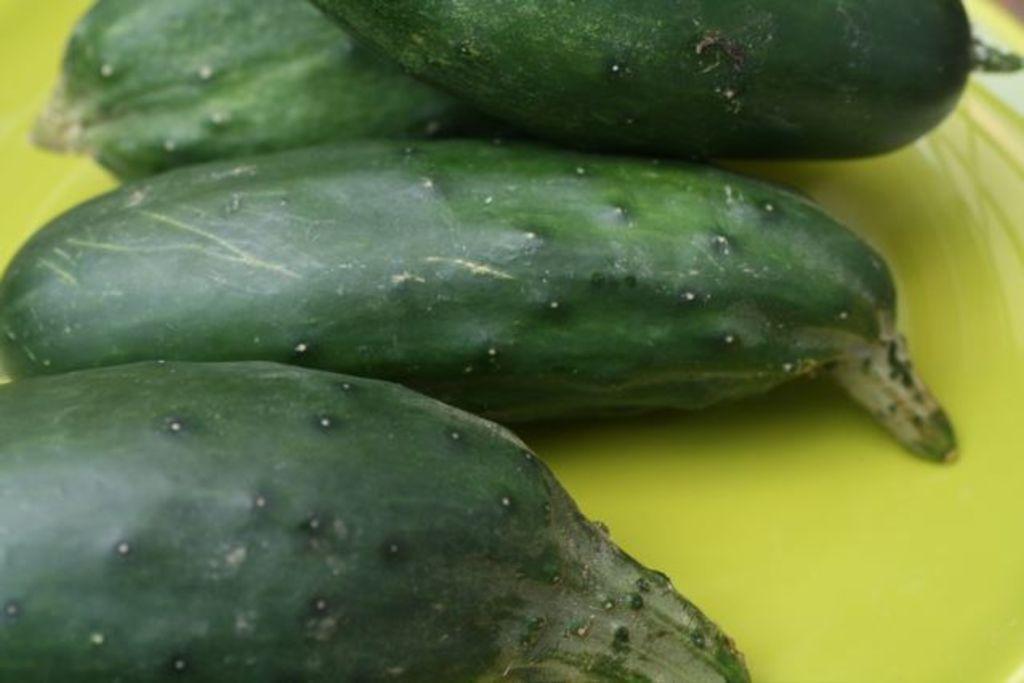Describe this image in one or two sentences. In which picture we can see a yellow plate in which there are vegetables. 